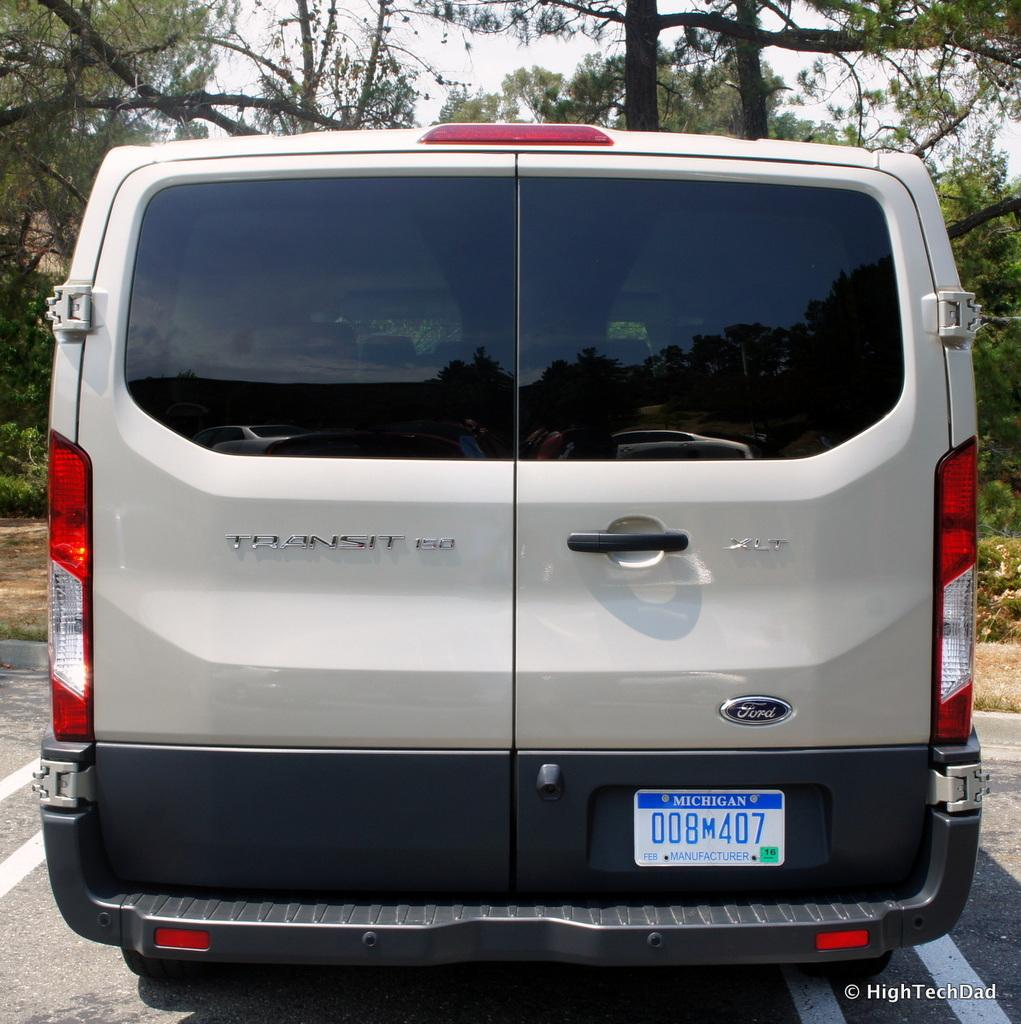What is the main subject of the image? There is a vehicle on a road in the image. What can be seen in the background of the image? There are trees visible in the background of the image. Is there any text present in the image? Yes, there is text present in the bottom right corner of the image. How many sisters are sitting on the seat of the vehicle in the image? There are no sisters or seats visible in the image; it only features a vehicle on a road. 